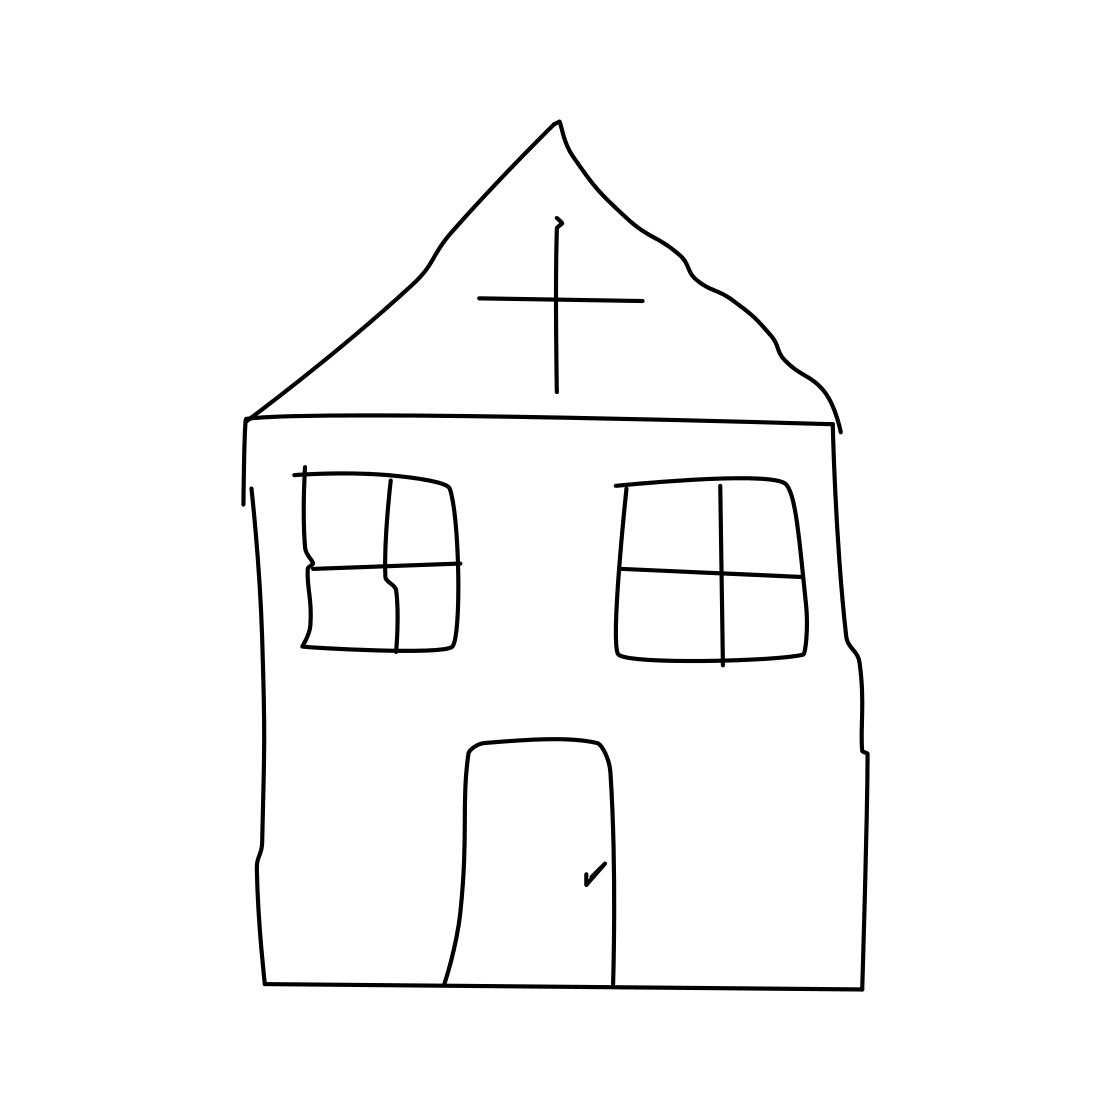What details can be observed on the church's facade? The church's facade in the drawing includes two square windows and a central doorway, all marked by very basic outlines. The simplicity of the depiction creates an intriguing minimalist aesthetic. 